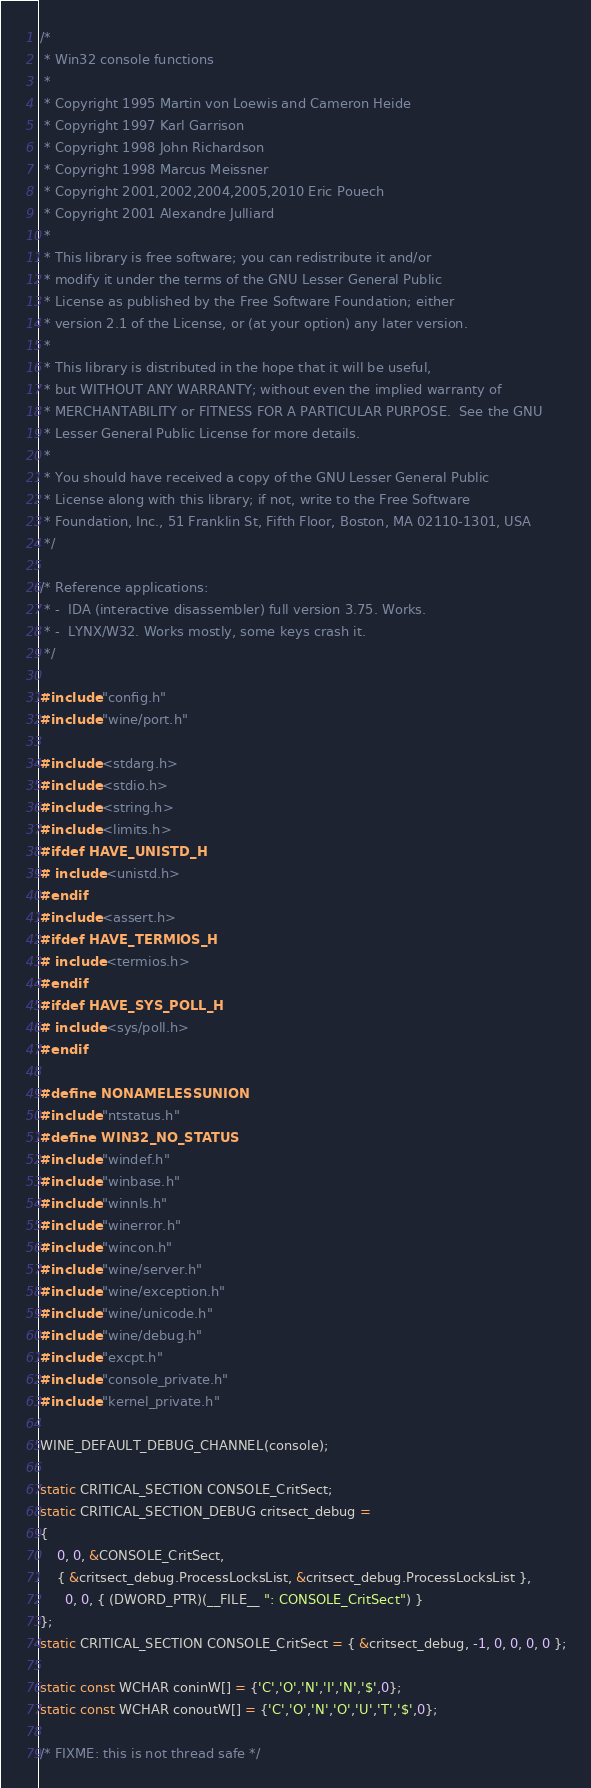<code> <loc_0><loc_0><loc_500><loc_500><_C_>/*
 * Win32 console functions
 *
 * Copyright 1995 Martin von Loewis and Cameron Heide
 * Copyright 1997 Karl Garrison
 * Copyright 1998 John Richardson
 * Copyright 1998 Marcus Meissner
 * Copyright 2001,2002,2004,2005,2010 Eric Pouech
 * Copyright 2001 Alexandre Julliard
 *
 * This library is free software; you can redistribute it and/or
 * modify it under the terms of the GNU Lesser General Public
 * License as published by the Free Software Foundation; either
 * version 2.1 of the License, or (at your option) any later version.
 *
 * This library is distributed in the hope that it will be useful,
 * but WITHOUT ANY WARRANTY; without even the implied warranty of
 * MERCHANTABILITY or FITNESS FOR A PARTICULAR PURPOSE.  See the GNU
 * Lesser General Public License for more details.
 *
 * You should have received a copy of the GNU Lesser General Public
 * License along with this library; if not, write to the Free Software
 * Foundation, Inc., 51 Franklin St, Fifth Floor, Boston, MA 02110-1301, USA
 */

/* Reference applications:
 * -  IDA (interactive disassembler) full version 3.75. Works.
 * -  LYNX/W32. Works mostly, some keys crash it.
 */

#include "config.h"
#include "wine/port.h"

#include <stdarg.h>
#include <stdio.h>
#include <string.h>
#include <limits.h>
#ifdef HAVE_UNISTD_H
# include <unistd.h>
#endif
#include <assert.h>
#ifdef HAVE_TERMIOS_H
# include <termios.h>
#endif
#ifdef HAVE_SYS_POLL_H
# include <sys/poll.h>
#endif

#define NONAMELESSUNION
#include "ntstatus.h"
#define WIN32_NO_STATUS
#include "windef.h"
#include "winbase.h"
#include "winnls.h"
#include "winerror.h"
#include "wincon.h"
#include "wine/server.h"
#include "wine/exception.h"
#include "wine/unicode.h"
#include "wine/debug.h"
#include "excpt.h"
#include "console_private.h"
#include "kernel_private.h"

WINE_DEFAULT_DEBUG_CHANNEL(console);

static CRITICAL_SECTION CONSOLE_CritSect;
static CRITICAL_SECTION_DEBUG critsect_debug =
{
    0, 0, &CONSOLE_CritSect,
    { &critsect_debug.ProcessLocksList, &critsect_debug.ProcessLocksList },
      0, 0, { (DWORD_PTR)(__FILE__ ": CONSOLE_CritSect") }
};
static CRITICAL_SECTION CONSOLE_CritSect = { &critsect_debug, -1, 0, 0, 0, 0 };

static const WCHAR coninW[] = {'C','O','N','I','N','$',0};
static const WCHAR conoutW[] = {'C','O','N','O','U','T','$',0};

/* FIXME: this is not thread safe */</code> 